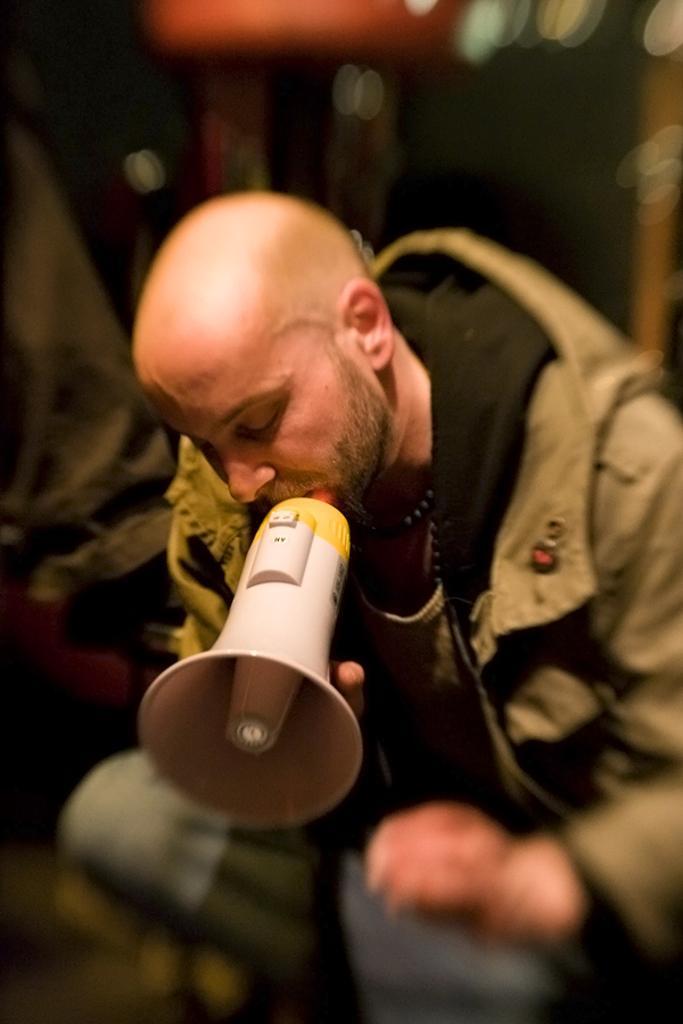Can you describe this image briefly? In the center of the image there is a person holding a mic in his hand. 